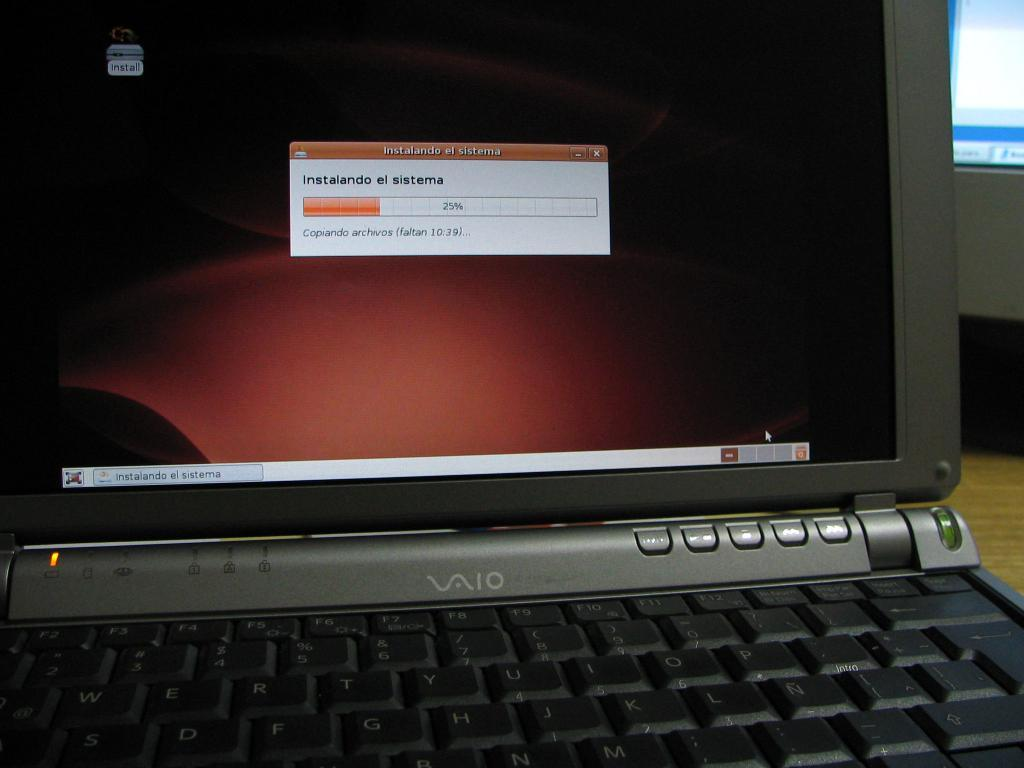<image>
Relay a brief, clear account of the picture shown. Valo laptop with a screen showing the download time at 25%. 